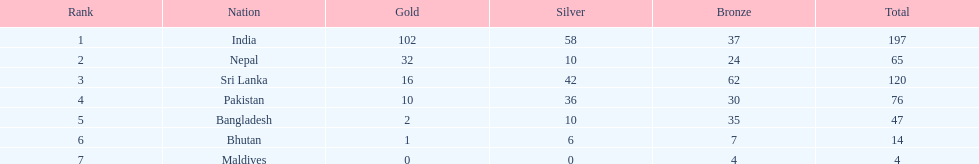How many gold medals did india win? 102. 